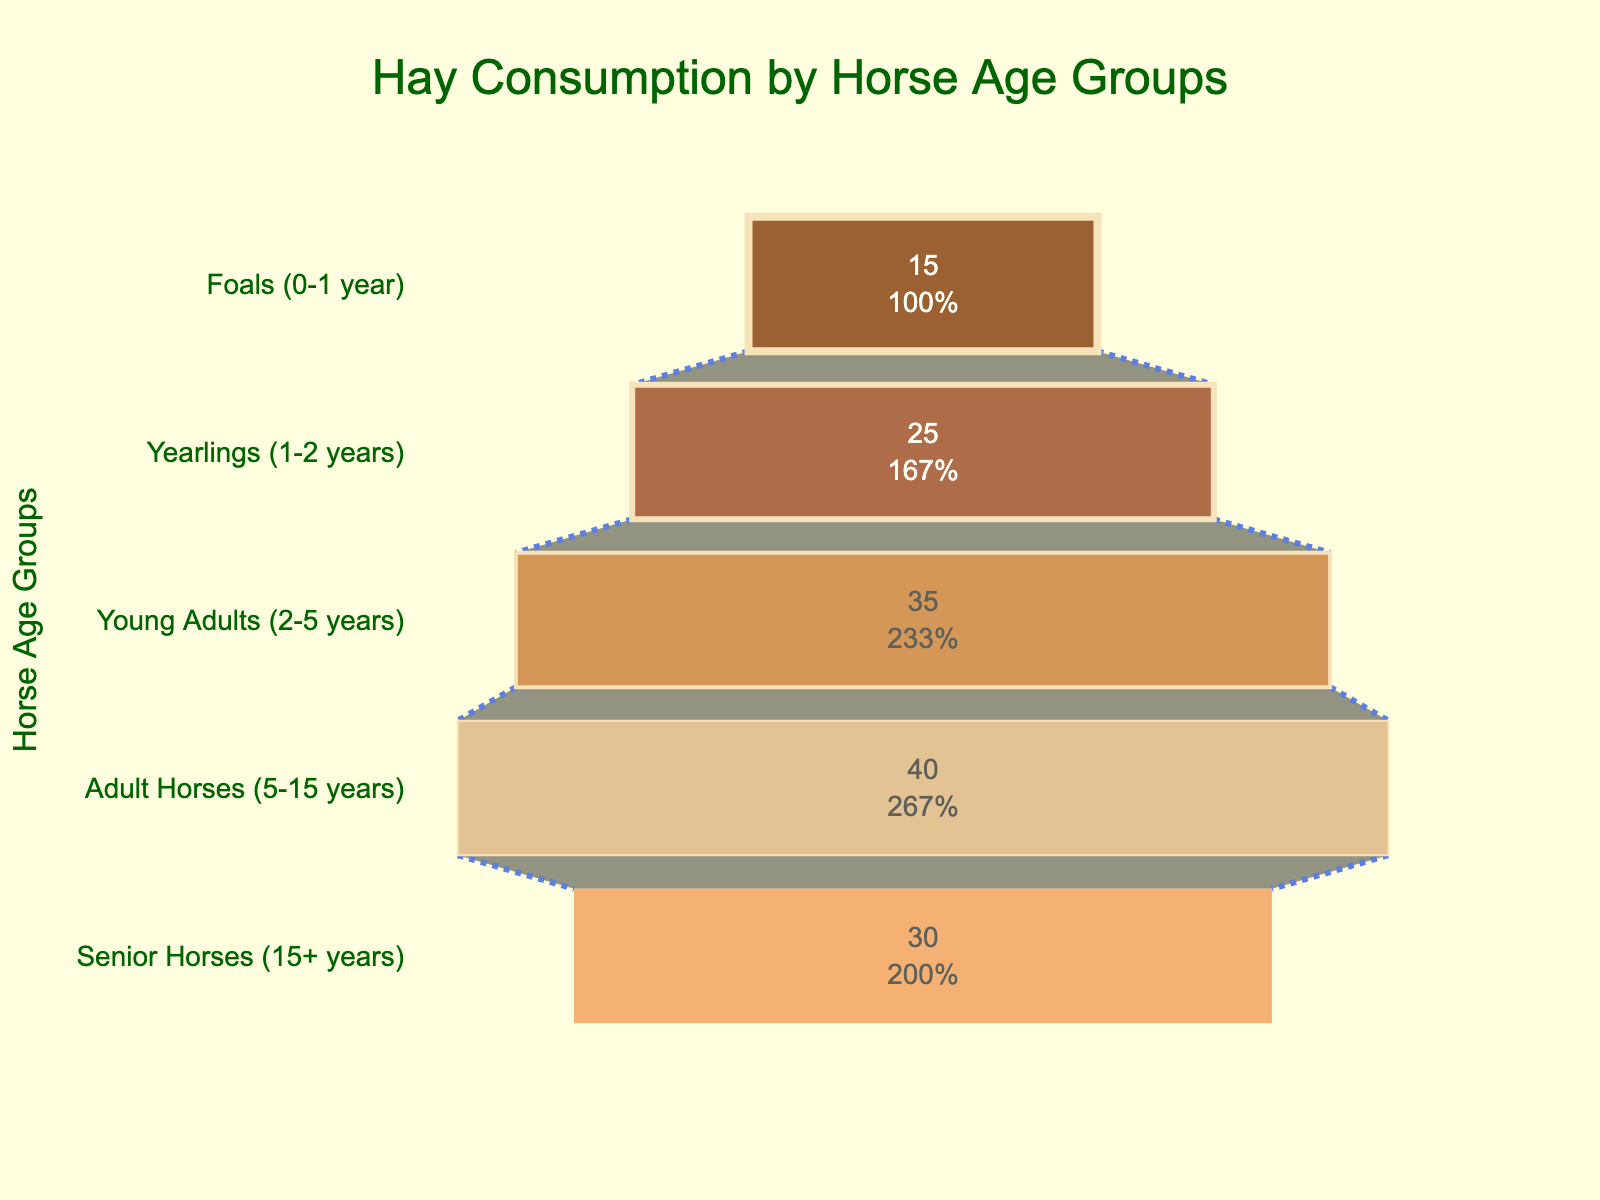What is the title of the funnel chart? The title is located at the top center of the chart in dark green font. It states the main purpose or topic of the chart.
Answer: Hay Consumption by Horse Age Groups What is the hay consumption for Young Adults (2-5 years)? Find the bar corresponding to the "Young Adults (2-5 years)" age group and read the hay consumption value inside the bar.
Answer: 35 tons per year Which age group consumes the least amount of hay? Look for the smallest bar in the funnel chart and identify the corresponding age group and its hay consumption.
Answer: Foals (0-1 year) How much more hay do Adult Horses (5-15 years) consume than Foals (0-1 year)? Locate the hay consumption values for both Adult Horses (40 tons) and Foals (15 tons). Subtract the Foals' consumption from the Adult Horses' consumption (40 - 15).
Answer: 25 tons per year What percentage of the initial hay consumption is consumed by Senior Horses (15+ years)? Inside the bar for Senior Horses (15+ years), look for the percentage value stated.
Answer: 25% What is the sum of hay consumption for all age groups? Add the hay consumption values of all age groups: 15 (Foals) + 25 (Yearlings) + 35 (Young Adults) + 40 (Adult Horses) + 30 (Senior Horses).
Answer: 145 tons per year Which age group has the highest hay consumption? Identify the largest bar in the funnel chart and read the corresponding age group and its hay consumption value.
Answer: Adult Horses (5-15 years) By how much does the hay consumption differ between Yearlings (1-2 years) and Senior Horses (15+ years)? Locate the hay consumption values for Yearlings (25 tons) and Senior Horses (30 tons). Subtract the smaller value from the larger value (30 - 25).
Answer: 5 tons per year How does the hay consumption trend change with age in the funnel chart? Observe the funnel chart from top to bottom, noting the changes in the width of each successive bar to understand the overall trend in consumption.
Answer: Increases from foals to adult horses, then decreases for senior horses What is the average hay consumption for all age groups? Sum all the hay consumption values (15 + 25 + 35 + 40 + 30) and divide by the number of age groups (5). Therefore, the average consumption is (145 / 5).
Answer: 29 tons per year 